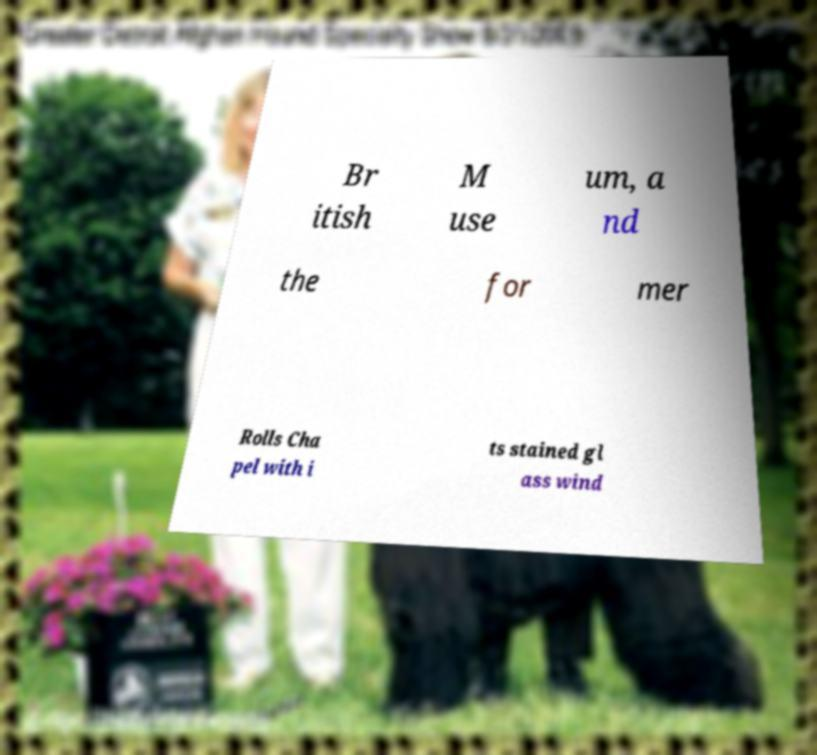There's text embedded in this image that I need extracted. Can you transcribe it verbatim? Br itish M use um, a nd the for mer Rolls Cha pel with i ts stained gl ass wind 